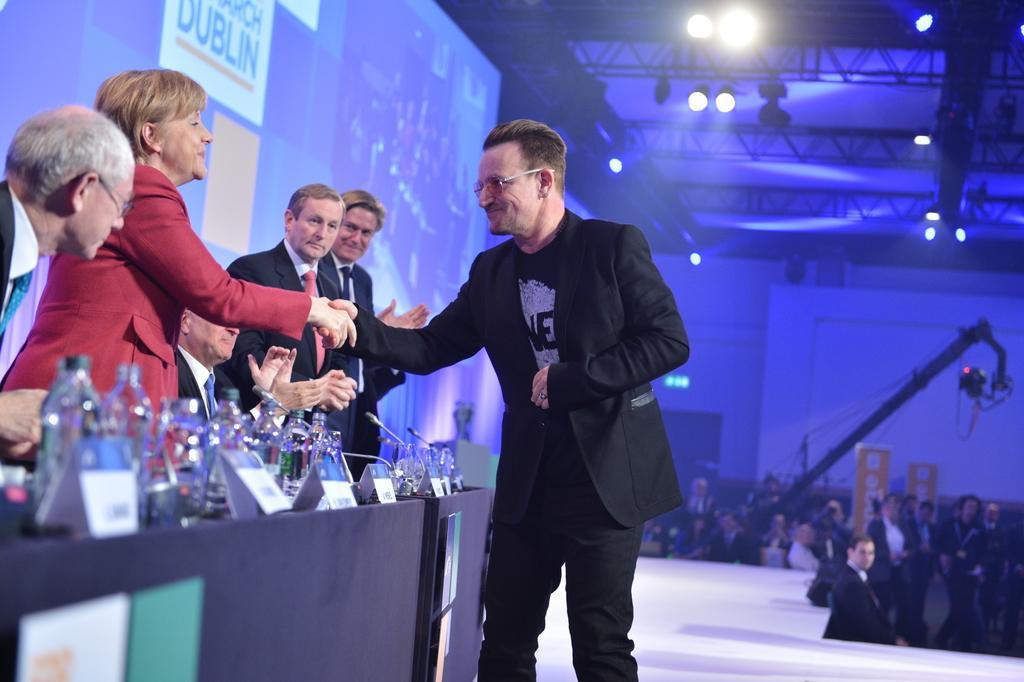Could you give a brief overview of what you see in this image? In this image, there are five people standing and a person sitting. Among them two people are hand shaking with each other. In front of these people, there is a table with water bottles, name boards, mikes and few other objects. On the right side of the image, I can see groups of people and a camera crane. At the top of the image, I can see the focus lights to the lighting trusses. Behind these people, there is a hoarding. 